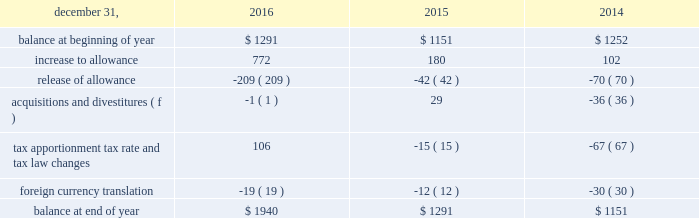In 2016 , arconic also recognized discrete income tax benefits related to the release of valuation allowances on certain net deferred tax assets in russia and canada of $ 19 and $ 20 respectively .
After weighing all available evidence , management determined that it was more likely than not that the net income tax benefits associated with the underlying deferred tax assets would be realizable based on historic cumulative income and projected taxable income .
Arconic also recorded additional valuation allowances in australia of $ 93 related to the separation transaction , in spain of $ 163 related to a tax law change and in luxembourg of $ 280 related to the separation transaction as well as a tax law change .
These valuation allowances fully offset current year changes in deferred tax asset balances of each respective jurisdiction , resulting in no net impact to tax expense .
The need for a valuation allowance will be reassessed on a continuous basis in future periods by each jurisdiction and , as a result , the allowances may increase or decrease based on changes in facts and circumstances .
In 2015 , arconic recognized an additional $ 141 discrete income tax charge for valuation allowances on certain deferred tax assets in iceland and suriname .
Of this amount , an $ 85 valuation allowance was established on the full value of the deferred tax assets in suriname , which were related mostly to employee benefits and tax loss carryforwards .
These deferred tax assets have an expiration period ranging from 2016 to 2022 ( as of december 31 , 2015 ) .
The remaining $ 56 charge relates to a valuation allowance established on a portion of the deferred tax assets recorded in iceland .
These deferred tax assets have an expiration period ranging from 2017 to 2023 .
After weighing all available positive and negative evidence , as described above , management determined that it was no longer more likely than not that arconic will realize the tax benefit of either of these deferred tax assets .
This was mainly driven by a decline in the outlook of the primary metals business , combined with prior year cumulative losses and a short expiration period .
In december 2011 , one of arconic 2019s former subsidiaries in brazil applied for a tax holiday related to its expanded mining and refining operations .
During 2013 , the application was amended and re-filed and , separately , a similar application was filed for another one of arconic 2019s former subsidiaries in brazil .
The deadline for the brazilian government to deny the application was july 11 , 2014 .
Since arconic did not receive notice that its applications were denied , the tax holiday took effect automatically on july 12 , 2014 .
As a result , the tax rate applicable to qualified holiday income for these subsidiaries decreased significantly ( from 34% ( 34 % ) to 15.25% ( 15.25 % ) ) , resulting in future cash tax savings over the 10-year holiday period ( retroactively effective as of january 1 , 2013 ) .
Additionally , a portion of one of the subsidiaries net deferred tax assets that reverses within the holiday period was remeasured at the new tax rate ( the net deferred tax asset of the other subsidiary was not remeasured since it could still be utilized against the subsidiary 2019s future earnings not subject to the tax holiday ) .
This remeasurement resulted in a decrease to that subsidiary 2019s net deferred tax assets and a noncash charge to earnings of $ 52 ( $ 31 after noncontrolling interests ) .
The table details the changes in the valuation allowance: .
The cumulative amount of arconic 2019s foreign undistributed net earnings for which no deferred taxes have been provided was approximately $ 450 at december 31 , 2016 .
Arconic has a number of commitments and obligations related to the company 2019s growth strategy in foreign jurisdictions .
As such , management has no plans to distribute such earnings in the foreseeable future , and , therefore , has determined it is not practicable to determine the related deferred tax liability. .
What was the increase in the increase to allowance value from 2015 to 2016? 
Rationale: it is the percentual increase observed in the increase to allowance value , which is calculated by dividing the 2016's value by the 2015's then turned into a percentage .
Computations: (((772 / 180) * 100) - 100)
Answer: 328.88889. 